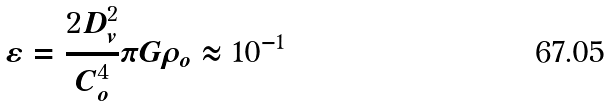Convert formula to latex. <formula><loc_0><loc_0><loc_500><loc_500>\varepsilon = \frac { 2 D _ { v } ^ { 2 } } { C _ { o } ^ { 4 } } \pi G \rho _ { o } \approx 1 0 ^ { - 1 }</formula> 